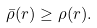<formula> <loc_0><loc_0><loc_500><loc_500>\bar { \rho } ( r ) \geq \rho ( r ) .</formula> 